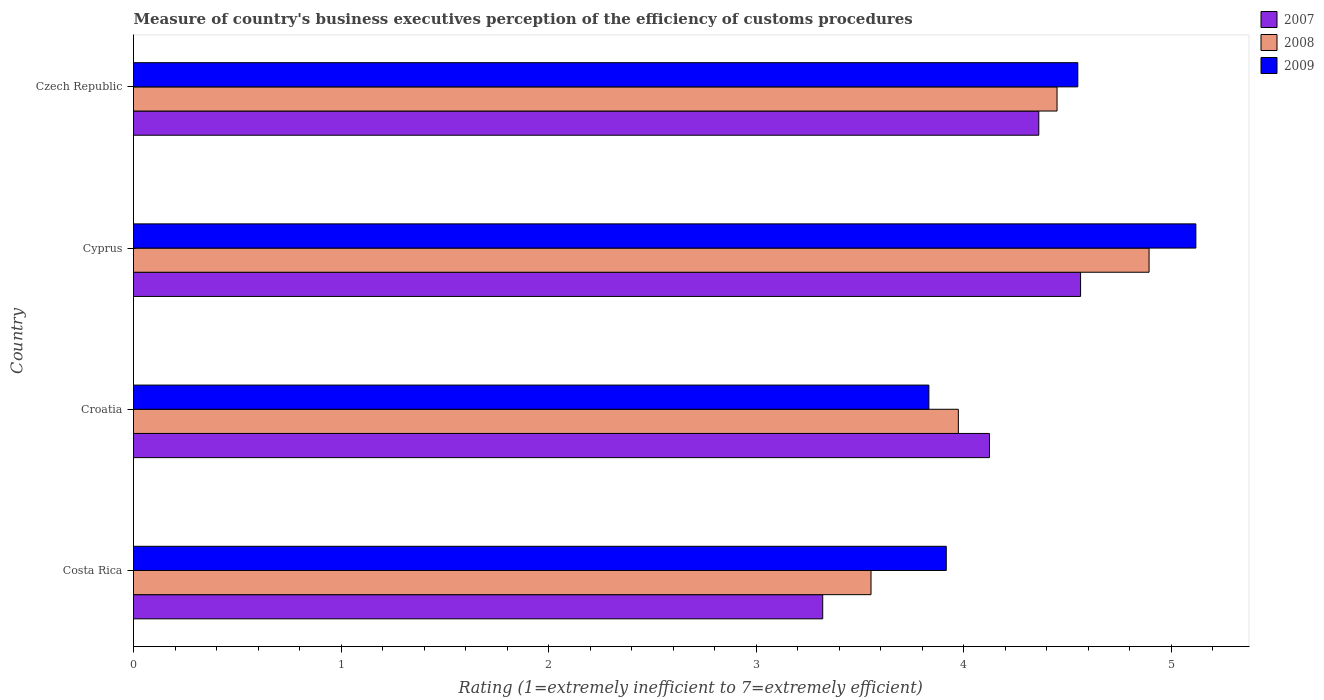How many different coloured bars are there?
Your response must be concise. 3. How many groups of bars are there?
Offer a very short reply. 4. Are the number of bars per tick equal to the number of legend labels?
Your answer should be compact. Yes. How many bars are there on the 3rd tick from the top?
Ensure brevity in your answer.  3. What is the label of the 4th group of bars from the top?
Ensure brevity in your answer.  Costa Rica. In how many cases, is the number of bars for a given country not equal to the number of legend labels?
Offer a terse response. 0. What is the rating of the efficiency of customs procedure in 2007 in Cyprus?
Offer a terse response. 4.56. Across all countries, what is the maximum rating of the efficiency of customs procedure in 2007?
Provide a succinct answer. 4.56. Across all countries, what is the minimum rating of the efficiency of customs procedure in 2008?
Give a very brief answer. 3.55. In which country was the rating of the efficiency of customs procedure in 2009 maximum?
Your response must be concise. Cyprus. What is the total rating of the efficiency of customs procedure in 2007 in the graph?
Ensure brevity in your answer.  16.37. What is the difference between the rating of the efficiency of customs procedure in 2007 in Costa Rica and that in Czech Republic?
Ensure brevity in your answer.  -1.04. What is the difference between the rating of the efficiency of customs procedure in 2009 in Croatia and the rating of the efficiency of customs procedure in 2008 in Cyprus?
Offer a very short reply. -1.06. What is the average rating of the efficiency of customs procedure in 2008 per country?
Your answer should be compact. 4.22. What is the difference between the rating of the efficiency of customs procedure in 2009 and rating of the efficiency of customs procedure in 2008 in Czech Republic?
Your answer should be compact. 0.1. What is the ratio of the rating of the efficiency of customs procedure in 2007 in Croatia to that in Cyprus?
Offer a very short reply. 0.9. Is the difference between the rating of the efficiency of customs procedure in 2009 in Costa Rica and Czech Republic greater than the difference between the rating of the efficiency of customs procedure in 2008 in Costa Rica and Czech Republic?
Your answer should be compact. Yes. What is the difference between the highest and the second highest rating of the efficiency of customs procedure in 2007?
Provide a succinct answer. 0.2. What is the difference between the highest and the lowest rating of the efficiency of customs procedure in 2007?
Make the answer very short. 1.24. In how many countries, is the rating of the efficiency of customs procedure in 2007 greater than the average rating of the efficiency of customs procedure in 2007 taken over all countries?
Your answer should be very brief. 3. What does the 3rd bar from the bottom in Croatia represents?
Your answer should be compact. 2009. Is it the case that in every country, the sum of the rating of the efficiency of customs procedure in 2008 and rating of the efficiency of customs procedure in 2007 is greater than the rating of the efficiency of customs procedure in 2009?
Provide a short and direct response. Yes. Are the values on the major ticks of X-axis written in scientific E-notation?
Your answer should be very brief. No. Does the graph contain grids?
Make the answer very short. No. How are the legend labels stacked?
Offer a very short reply. Vertical. What is the title of the graph?
Give a very brief answer. Measure of country's business executives perception of the efficiency of customs procedures. Does "1964" appear as one of the legend labels in the graph?
Ensure brevity in your answer.  No. What is the label or title of the X-axis?
Offer a terse response. Rating (1=extremely inefficient to 7=extremely efficient). What is the label or title of the Y-axis?
Offer a very short reply. Country. What is the Rating (1=extremely inefficient to 7=extremely efficient) of 2007 in Costa Rica?
Provide a succinct answer. 3.32. What is the Rating (1=extremely inefficient to 7=extremely efficient) in 2008 in Costa Rica?
Provide a short and direct response. 3.55. What is the Rating (1=extremely inefficient to 7=extremely efficient) of 2009 in Costa Rica?
Give a very brief answer. 3.92. What is the Rating (1=extremely inefficient to 7=extremely efficient) in 2007 in Croatia?
Provide a succinct answer. 4.12. What is the Rating (1=extremely inefficient to 7=extremely efficient) of 2008 in Croatia?
Give a very brief answer. 3.98. What is the Rating (1=extremely inefficient to 7=extremely efficient) in 2009 in Croatia?
Your answer should be very brief. 3.83. What is the Rating (1=extremely inefficient to 7=extremely efficient) of 2007 in Cyprus?
Offer a terse response. 4.56. What is the Rating (1=extremely inefficient to 7=extremely efficient) in 2008 in Cyprus?
Your response must be concise. 4.89. What is the Rating (1=extremely inefficient to 7=extremely efficient) of 2009 in Cyprus?
Offer a very short reply. 5.12. What is the Rating (1=extremely inefficient to 7=extremely efficient) in 2007 in Czech Republic?
Keep it short and to the point. 4.36. What is the Rating (1=extremely inefficient to 7=extremely efficient) of 2008 in Czech Republic?
Give a very brief answer. 4.45. What is the Rating (1=extremely inefficient to 7=extremely efficient) of 2009 in Czech Republic?
Offer a very short reply. 4.55. Across all countries, what is the maximum Rating (1=extremely inefficient to 7=extremely efficient) of 2007?
Provide a succinct answer. 4.56. Across all countries, what is the maximum Rating (1=extremely inefficient to 7=extremely efficient) in 2008?
Your answer should be very brief. 4.89. Across all countries, what is the maximum Rating (1=extremely inefficient to 7=extremely efficient) in 2009?
Provide a succinct answer. 5.12. Across all countries, what is the minimum Rating (1=extremely inefficient to 7=extremely efficient) of 2007?
Keep it short and to the point. 3.32. Across all countries, what is the minimum Rating (1=extremely inefficient to 7=extremely efficient) of 2008?
Ensure brevity in your answer.  3.55. Across all countries, what is the minimum Rating (1=extremely inefficient to 7=extremely efficient) of 2009?
Provide a short and direct response. 3.83. What is the total Rating (1=extremely inefficient to 7=extremely efficient) in 2007 in the graph?
Keep it short and to the point. 16.37. What is the total Rating (1=extremely inefficient to 7=extremely efficient) in 2008 in the graph?
Offer a very short reply. 16.87. What is the total Rating (1=extremely inefficient to 7=extremely efficient) of 2009 in the graph?
Keep it short and to the point. 17.42. What is the difference between the Rating (1=extremely inefficient to 7=extremely efficient) in 2007 in Costa Rica and that in Croatia?
Ensure brevity in your answer.  -0.8. What is the difference between the Rating (1=extremely inefficient to 7=extremely efficient) in 2008 in Costa Rica and that in Croatia?
Your response must be concise. -0.42. What is the difference between the Rating (1=extremely inefficient to 7=extremely efficient) in 2009 in Costa Rica and that in Croatia?
Offer a very short reply. 0.08. What is the difference between the Rating (1=extremely inefficient to 7=extremely efficient) of 2007 in Costa Rica and that in Cyprus?
Your answer should be very brief. -1.24. What is the difference between the Rating (1=extremely inefficient to 7=extremely efficient) of 2008 in Costa Rica and that in Cyprus?
Provide a succinct answer. -1.34. What is the difference between the Rating (1=extremely inefficient to 7=extremely efficient) of 2009 in Costa Rica and that in Cyprus?
Provide a short and direct response. -1.2. What is the difference between the Rating (1=extremely inefficient to 7=extremely efficient) of 2007 in Costa Rica and that in Czech Republic?
Offer a terse response. -1.04. What is the difference between the Rating (1=extremely inefficient to 7=extremely efficient) in 2008 in Costa Rica and that in Czech Republic?
Your answer should be very brief. -0.9. What is the difference between the Rating (1=extremely inefficient to 7=extremely efficient) in 2009 in Costa Rica and that in Czech Republic?
Provide a short and direct response. -0.63. What is the difference between the Rating (1=extremely inefficient to 7=extremely efficient) in 2007 in Croatia and that in Cyprus?
Provide a succinct answer. -0.44. What is the difference between the Rating (1=extremely inefficient to 7=extremely efficient) in 2008 in Croatia and that in Cyprus?
Offer a very short reply. -0.92. What is the difference between the Rating (1=extremely inefficient to 7=extremely efficient) in 2009 in Croatia and that in Cyprus?
Your answer should be compact. -1.29. What is the difference between the Rating (1=extremely inefficient to 7=extremely efficient) in 2007 in Croatia and that in Czech Republic?
Offer a very short reply. -0.24. What is the difference between the Rating (1=extremely inefficient to 7=extremely efficient) in 2008 in Croatia and that in Czech Republic?
Your response must be concise. -0.48. What is the difference between the Rating (1=extremely inefficient to 7=extremely efficient) in 2009 in Croatia and that in Czech Republic?
Provide a short and direct response. -0.72. What is the difference between the Rating (1=extremely inefficient to 7=extremely efficient) of 2007 in Cyprus and that in Czech Republic?
Offer a terse response. 0.2. What is the difference between the Rating (1=extremely inefficient to 7=extremely efficient) in 2008 in Cyprus and that in Czech Republic?
Provide a succinct answer. 0.44. What is the difference between the Rating (1=extremely inefficient to 7=extremely efficient) in 2009 in Cyprus and that in Czech Republic?
Make the answer very short. 0.57. What is the difference between the Rating (1=extremely inefficient to 7=extremely efficient) of 2007 in Costa Rica and the Rating (1=extremely inefficient to 7=extremely efficient) of 2008 in Croatia?
Make the answer very short. -0.65. What is the difference between the Rating (1=extremely inefficient to 7=extremely efficient) in 2007 in Costa Rica and the Rating (1=extremely inefficient to 7=extremely efficient) in 2009 in Croatia?
Your answer should be very brief. -0.51. What is the difference between the Rating (1=extremely inefficient to 7=extremely efficient) in 2008 in Costa Rica and the Rating (1=extremely inefficient to 7=extremely efficient) in 2009 in Croatia?
Your response must be concise. -0.28. What is the difference between the Rating (1=extremely inefficient to 7=extremely efficient) in 2007 in Costa Rica and the Rating (1=extremely inefficient to 7=extremely efficient) in 2008 in Cyprus?
Keep it short and to the point. -1.57. What is the difference between the Rating (1=extremely inefficient to 7=extremely efficient) in 2007 in Costa Rica and the Rating (1=extremely inefficient to 7=extremely efficient) in 2009 in Cyprus?
Your response must be concise. -1.8. What is the difference between the Rating (1=extremely inefficient to 7=extremely efficient) of 2008 in Costa Rica and the Rating (1=extremely inefficient to 7=extremely efficient) of 2009 in Cyprus?
Provide a short and direct response. -1.57. What is the difference between the Rating (1=extremely inefficient to 7=extremely efficient) of 2007 in Costa Rica and the Rating (1=extremely inefficient to 7=extremely efficient) of 2008 in Czech Republic?
Provide a short and direct response. -1.13. What is the difference between the Rating (1=extremely inefficient to 7=extremely efficient) of 2007 in Costa Rica and the Rating (1=extremely inefficient to 7=extremely efficient) of 2009 in Czech Republic?
Your response must be concise. -1.23. What is the difference between the Rating (1=extremely inefficient to 7=extremely efficient) of 2008 in Costa Rica and the Rating (1=extremely inefficient to 7=extremely efficient) of 2009 in Czech Republic?
Your answer should be very brief. -1. What is the difference between the Rating (1=extremely inefficient to 7=extremely efficient) of 2007 in Croatia and the Rating (1=extremely inefficient to 7=extremely efficient) of 2008 in Cyprus?
Make the answer very short. -0.77. What is the difference between the Rating (1=extremely inefficient to 7=extremely efficient) of 2007 in Croatia and the Rating (1=extremely inefficient to 7=extremely efficient) of 2009 in Cyprus?
Provide a succinct answer. -0.99. What is the difference between the Rating (1=extremely inefficient to 7=extremely efficient) in 2008 in Croatia and the Rating (1=extremely inefficient to 7=extremely efficient) in 2009 in Cyprus?
Make the answer very short. -1.14. What is the difference between the Rating (1=extremely inefficient to 7=extremely efficient) of 2007 in Croatia and the Rating (1=extremely inefficient to 7=extremely efficient) of 2008 in Czech Republic?
Provide a succinct answer. -0.33. What is the difference between the Rating (1=extremely inefficient to 7=extremely efficient) of 2007 in Croatia and the Rating (1=extremely inefficient to 7=extremely efficient) of 2009 in Czech Republic?
Keep it short and to the point. -0.43. What is the difference between the Rating (1=extremely inefficient to 7=extremely efficient) in 2008 in Croatia and the Rating (1=extremely inefficient to 7=extremely efficient) in 2009 in Czech Republic?
Your response must be concise. -0.58. What is the difference between the Rating (1=extremely inefficient to 7=extremely efficient) of 2007 in Cyprus and the Rating (1=extremely inefficient to 7=extremely efficient) of 2008 in Czech Republic?
Make the answer very short. 0.11. What is the difference between the Rating (1=extremely inefficient to 7=extremely efficient) of 2007 in Cyprus and the Rating (1=extremely inefficient to 7=extremely efficient) of 2009 in Czech Republic?
Provide a short and direct response. 0.01. What is the difference between the Rating (1=extremely inefficient to 7=extremely efficient) of 2008 in Cyprus and the Rating (1=extremely inefficient to 7=extremely efficient) of 2009 in Czech Republic?
Give a very brief answer. 0.34. What is the average Rating (1=extremely inefficient to 7=extremely efficient) of 2007 per country?
Keep it short and to the point. 4.09. What is the average Rating (1=extremely inefficient to 7=extremely efficient) in 2008 per country?
Keep it short and to the point. 4.22. What is the average Rating (1=extremely inefficient to 7=extremely efficient) in 2009 per country?
Give a very brief answer. 4.36. What is the difference between the Rating (1=extremely inefficient to 7=extremely efficient) in 2007 and Rating (1=extremely inefficient to 7=extremely efficient) in 2008 in Costa Rica?
Provide a succinct answer. -0.23. What is the difference between the Rating (1=extremely inefficient to 7=extremely efficient) of 2007 and Rating (1=extremely inefficient to 7=extremely efficient) of 2009 in Costa Rica?
Offer a very short reply. -0.6. What is the difference between the Rating (1=extremely inefficient to 7=extremely efficient) of 2008 and Rating (1=extremely inefficient to 7=extremely efficient) of 2009 in Costa Rica?
Your response must be concise. -0.36. What is the difference between the Rating (1=extremely inefficient to 7=extremely efficient) of 2007 and Rating (1=extremely inefficient to 7=extremely efficient) of 2008 in Croatia?
Your answer should be compact. 0.15. What is the difference between the Rating (1=extremely inefficient to 7=extremely efficient) in 2007 and Rating (1=extremely inefficient to 7=extremely efficient) in 2009 in Croatia?
Your answer should be very brief. 0.29. What is the difference between the Rating (1=extremely inefficient to 7=extremely efficient) in 2008 and Rating (1=extremely inefficient to 7=extremely efficient) in 2009 in Croatia?
Your response must be concise. 0.14. What is the difference between the Rating (1=extremely inefficient to 7=extremely efficient) in 2007 and Rating (1=extremely inefficient to 7=extremely efficient) in 2008 in Cyprus?
Your answer should be very brief. -0.33. What is the difference between the Rating (1=extremely inefficient to 7=extremely efficient) in 2007 and Rating (1=extremely inefficient to 7=extremely efficient) in 2009 in Cyprus?
Ensure brevity in your answer.  -0.56. What is the difference between the Rating (1=extremely inefficient to 7=extremely efficient) of 2008 and Rating (1=extremely inefficient to 7=extremely efficient) of 2009 in Cyprus?
Offer a terse response. -0.23. What is the difference between the Rating (1=extremely inefficient to 7=extremely efficient) in 2007 and Rating (1=extremely inefficient to 7=extremely efficient) in 2008 in Czech Republic?
Offer a very short reply. -0.09. What is the difference between the Rating (1=extremely inefficient to 7=extremely efficient) in 2007 and Rating (1=extremely inefficient to 7=extremely efficient) in 2009 in Czech Republic?
Your response must be concise. -0.19. What is the difference between the Rating (1=extremely inefficient to 7=extremely efficient) of 2008 and Rating (1=extremely inefficient to 7=extremely efficient) of 2009 in Czech Republic?
Your response must be concise. -0.1. What is the ratio of the Rating (1=extremely inefficient to 7=extremely efficient) of 2007 in Costa Rica to that in Croatia?
Provide a short and direct response. 0.81. What is the ratio of the Rating (1=extremely inefficient to 7=extremely efficient) of 2008 in Costa Rica to that in Croatia?
Offer a very short reply. 0.89. What is the ratio of the Rating (1=extremely inefficient to 7=extremely efficient) of 2009 in Costa Rica to that in Croatia?
Make the answer very short. 1.02. What is the ratio of the Rating (1=extremely inefficient to 7=extremely efficient) of 2007 in Costa Rica to that in Cyprus?
Your answer should be very brief. 0.73. What is the ratio of the Rating (1=extremely inefficient to 7=extremely efficient) in 2008 in Costa Rica to that in Cyprus?
Provide a succinct answer. 0.73. What is the ratio of the Rating (1=extremely inefficient to 7=extremely efficient) of 2009 in Costa Rica to that in Cyprus?
Offer a very short reply. 0.77. What is the ratio of the Rating (1=extremely inefficient to 7=extremely efficient) of 2007 in Costa Rica to that in Czech Republic?
Your answer should be very brief. 0.76. What is the ratio of the Rating (1=extremely inefficient to 7=extremely efficient) in 2008 in Costa Rica to that in Czech Republic?
Give a very brief answer. 0.8. What is the ratio of the Rating (1=extremely inefficient to 7=extremely efficient) in 2009 in Costa Rica to that in Czech Republic?
Your answer should be compact. 0.86. What is the ratio of the Rating (1=extremely inefficient to 7=extremely efficient) of 2007 in Croatia to that in Cyprus?
Offer a very short reply. 0.9. What is the ratio of the Rating (1=extremely inefficient to 7=extremely efficient) in 2008 in Croatia to that in Cyprus?
Your answer should be compact. 0.81. What is the ratio of the Rating (1=extremely inefficient to 7=extremely efficient) in 2009 in Croatia to that in Cyprus?
Give a very brief answer. 0.75. What is the ratio of the Rating (1=extremely inefficient to 7=extremely efficient) in 2007 in Croatia to that in Czech Republic?
Your answer should be compact. 0.95. What is the ratio of the Rating (1=extremely inefficient to 7=extremely efficient) of 2008 in Croatia to that in Czech Republic?
Keep it short and to the point. 0.89. What is the ratio of the Rating (1=extremely inefficient to 7=extremely efficient) in 2009 in Croatia to that in Czech Republic?
Offer a terse response. 0.84. What is the ratio of the Rating (1=extremely inefficient to 7=extremely efficient) in 2007 in Cyprus to that in Czech Republic?
Offer a terse response. 1.05. What is the ratio of the Rating (1=extremely inefficient to 7=extremely efficient) of 2008 in Cyprus to that in Czech Republic?
Your answer should be compact. 1.1. What is the ratio of the Rating (1=extremely inefficient to 7=extremely efficient) of 2009 in Cyprus to that in Czech Republic?
Provide a short and direct response. 1.12. What is the difference between the highest and the second highest Rating (1=extremely inefficient to 7=extremely efficient) of 2007?
Give a very brief answer. 0.2. What is the difference between the highest and the second highest Rating (1=extremely inefficient to 7=extremely efficient) of 2008?
Ensure brevity in your answer.  0.44. What is the difference between the highest and the second highest Rating (1=extremely inefficient to 7=extremely efficient) in 2009?
Make the answer very short. 0.57. What is the difference between the highest and the lowest Rating (1=extremely inefficient to 7=extremely efficient) of 2007?
Give a very brief answer. 1.24. What is the difference between the highest and the lowest Rating (1=extremely inefficient to 7=extremely efficient) in 2008?
Provide a succinct answer. 1.34. What is the difference between the highest and the lowest Rating (1=extremely inefficient to 7=extremely efficient) of 2009?
Your response must be concise. 1.29. 